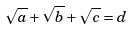<formula> <loc_0><loc_0><loc_500><loc_500>\sqrt { a } + \sqrt { b } + \sqrt { c } = d</formula> 